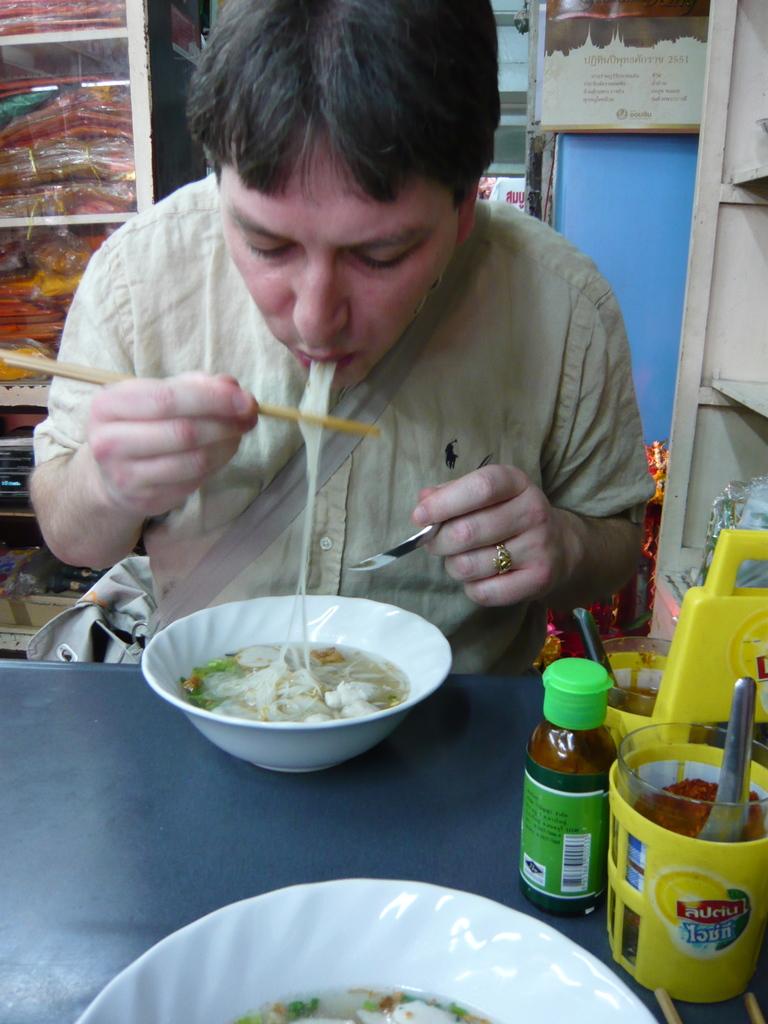Are the words in the yellow cup english?
Offer a very short reply. No. 